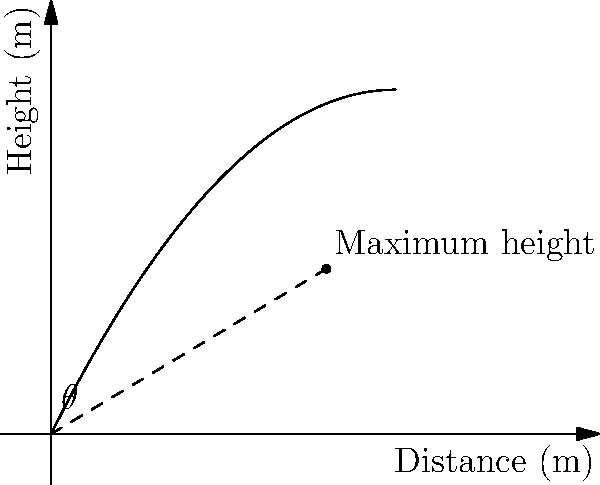In a professional volleyball match, a player is preparing to spike the ball. The path of the ball can be modeled by the parabolic function $h(x) = -0.1x^2 + 2x$, where $h$ is the height of the ball in meters and $x$ is the horizontal distance from the player in meters. What is the optimal angle $\theta$ (in degrees) for the player to hit the ball to achieve maximum height? To find the optimal angle, we need to follow these steps:

1) First, we need to find the maximum point of the parabola. We can do this by finding the vertex of the parabola.

2) For a quadratic function in the form $f(x) = ax^2 + bx + c$, the x-coordinate of the vertex is given by $x = -\frac{b}{2a}$.

3) In our function $h(x) = -0.1x^2 + 2x$, $a = -0.1$ and $b = 2$. So:
   
   $x = -\frac{2}{2(-0.1)} = -\frac{2}{-0.2} = 10$

4) The maximum point occurs at $x = 10$ meters.

5) Now, we can form a right triangle from the origin to this maximum point. The base of this triangle is 10 meters, and we can find the height by plugging $x = 10$ into our original function:

   $h(10) = -0.1(10)^2 + 2(10) = -10 + 20 = 10$ meters

6) We now have a right triangle with base 10 and height 10. We can find the angle using the arctangent function:

   $\theta = \arctan(\frac{10}{10}) = \arctan(1) = 45°$

Therefore, the optimal angle for the spike is 45°.
Answer: 45° 